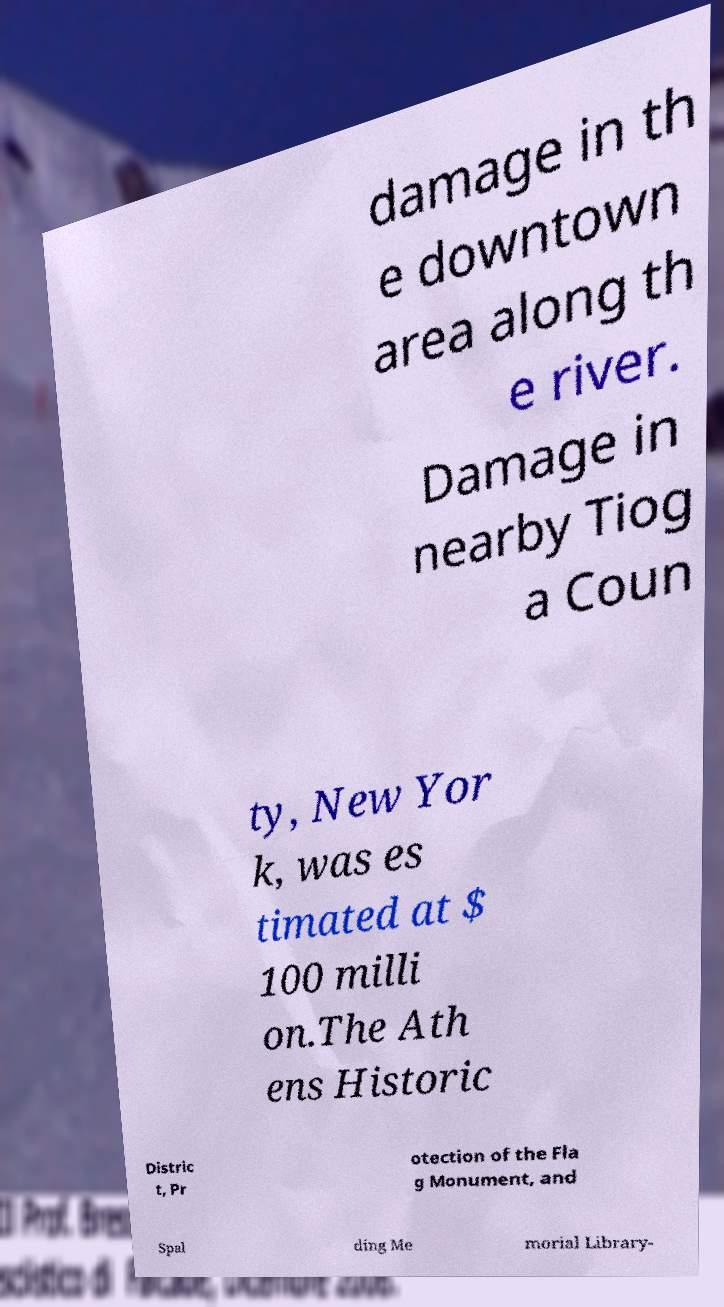For documentation purposes, I need the text within this image transcribed. Could you provide that? damage in th e downtown area along th e river. Damage in nearby Tiog a Coun ty, New Yor k, was es timated at $ 100 milli on.The Ath ens Historic Distric t, Pr otection of the Fla g Monument, and Spal ding Me morial Library- 